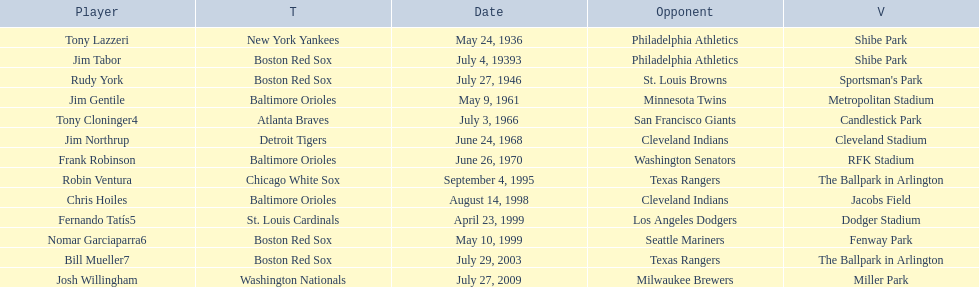What are the dates? May 24, 1936, July 4, 19393, July 27, 1946, May 9, 1961, July 3, 1966, June 24, 1968, June 26, 1970, September 4, 1995, August 14, 1998, April 23, 1999, May 10, 1999, July 29, 2003, July 27, 2009. Which date is in 1936? May 24, 1936. What player is listed for this date? Tony Lazzeri. 